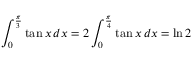<formula> <loc_0><loc_0><loc_500><loc_500>\int _ { 0 } ^ { \frac { \pi } { 3 } } \tan x \, d x = 2 \int _ { 0 } ^ { \frac { \pi } { 4 } } \tan x \, d x = \ln 2</formula> 